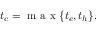Convert formula to latex. <formula><loc_0><loc_0><loc_500><loc_500>t _ { c } = m a x \{ t _ { e } , t _ { h } \} .</formula> 